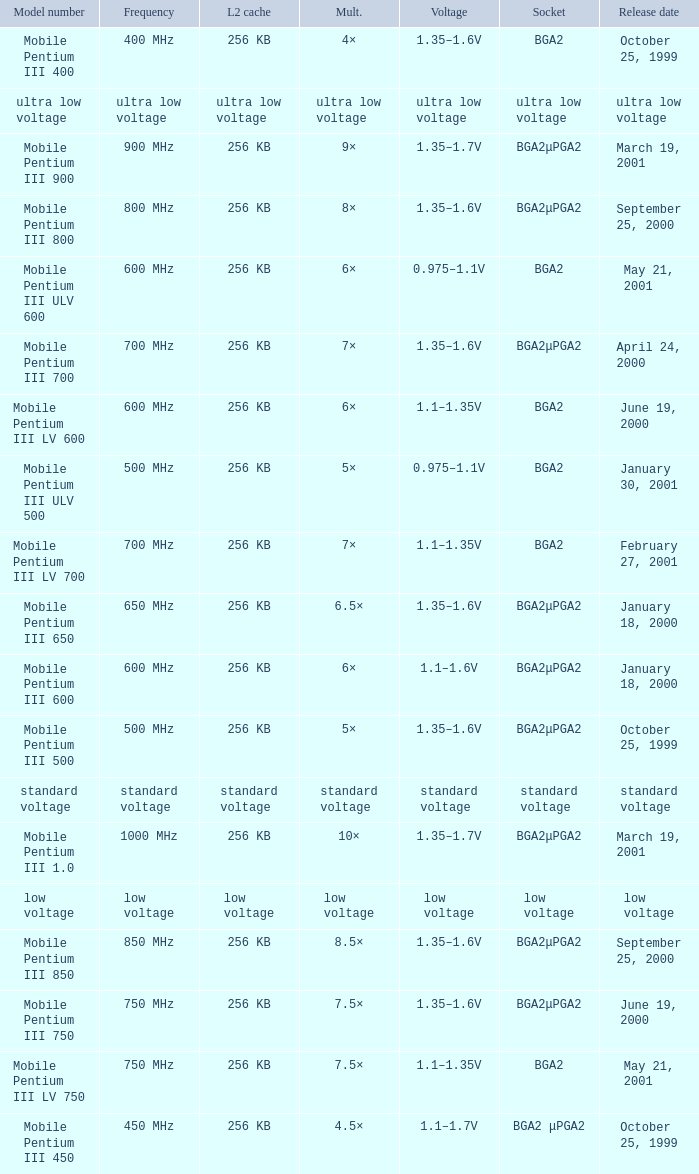What model number uses standard voltage socket? Standard voltage. 